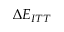<formula> <loc_0><loc_0><loc_500><loc_500>\Delta E _ { I T T }</formula> 